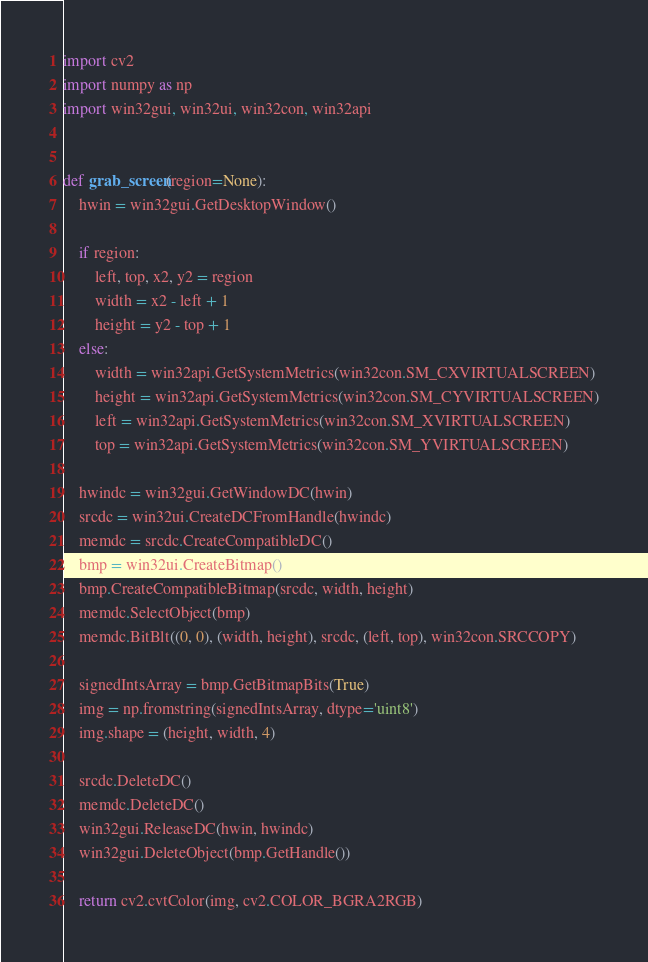<code> <loc_0><loc_0><loc_500><loc_500><_Python_>import cv2
import numpy as np
import win32gui, win32ui, win32con, win32api


def grab_screen(region=None):
    hwin = win32gui.GetDesktopWindow()

    if region:
        left, top, x2, y2 = region
        width = x2 - left + 1
        height = y2 - top + 1
    else:
        width = win32api.GetSystemMetrics(win32con.SM_CXVIRTUALSCREEN)
        height = win32api.GetSystemMetrics(win32con.SM_CYVIRTUALSCREEN)
        left = win32api.GetSystemMetrics(win32con.SM_XVIRTUALSCREEN)
        top = win32api.GetSystemMetrics(win32con.SM_YVIRTUALSCREEN)

    hwindc = win32gui.GetWindowDC(hwin)
    srcdc = win32ui.CreateDCFromHandle(hwindc)
    memdc = srcdc.CreateCompatibleDC()
    bmp = win32ui.CreateBitmap()
    bmp.CreateCompatibleBitmap(srcdc, width, height)
    memdc.SelectObject(bmp)
    memdc.BitBlt((0, 0), (width, height), srcdc, (left, top), win32con.SRCCOPY)

    signedIntsArray = bmp.GetBitmapBits(True)
    img = np.fromstring(signedIntsArray, dtype='uint8')
    img.shape = (height, width, 4)

    srcdc.DeleteDC()
    memdc.DeleteDC()
    win32gui.ReleaseDC(hwin, hwindc)
    win32gui.DeleteObject(bmp.GetHandle())

    return cv2.cvtColor(img, cv2.COLOR_BGRA2RGB)</code> 